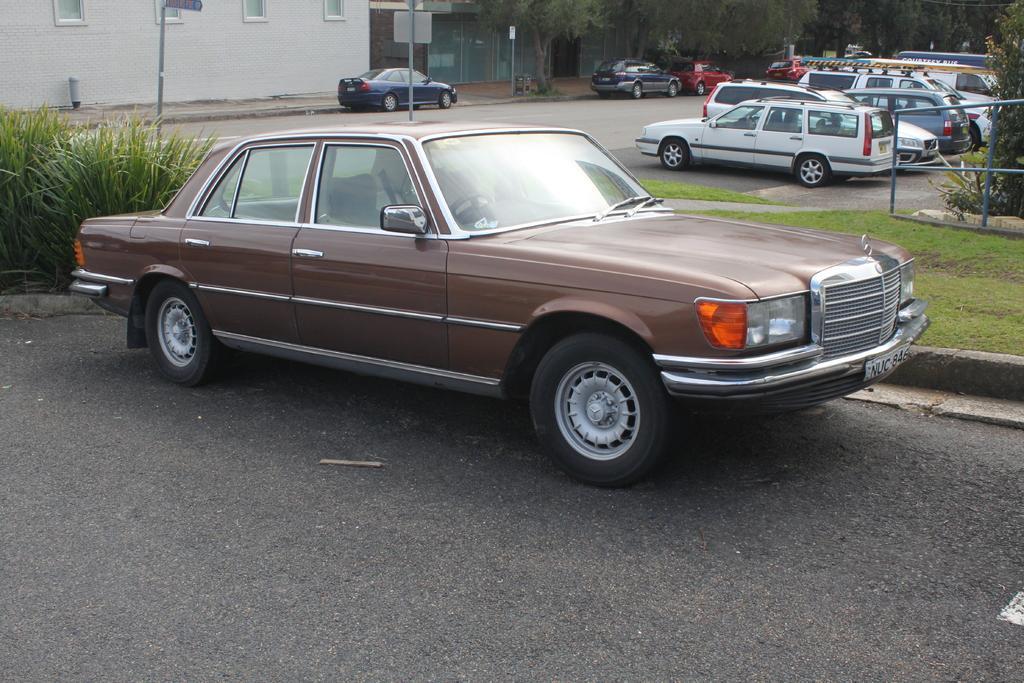Describe this image in one or two sentences. In this picture we can see a few vehicles on the road. There is some grass on the right and left side of the image. We can see a plant on the right side. There are a few poles, fence, trees and buildings in the background. 